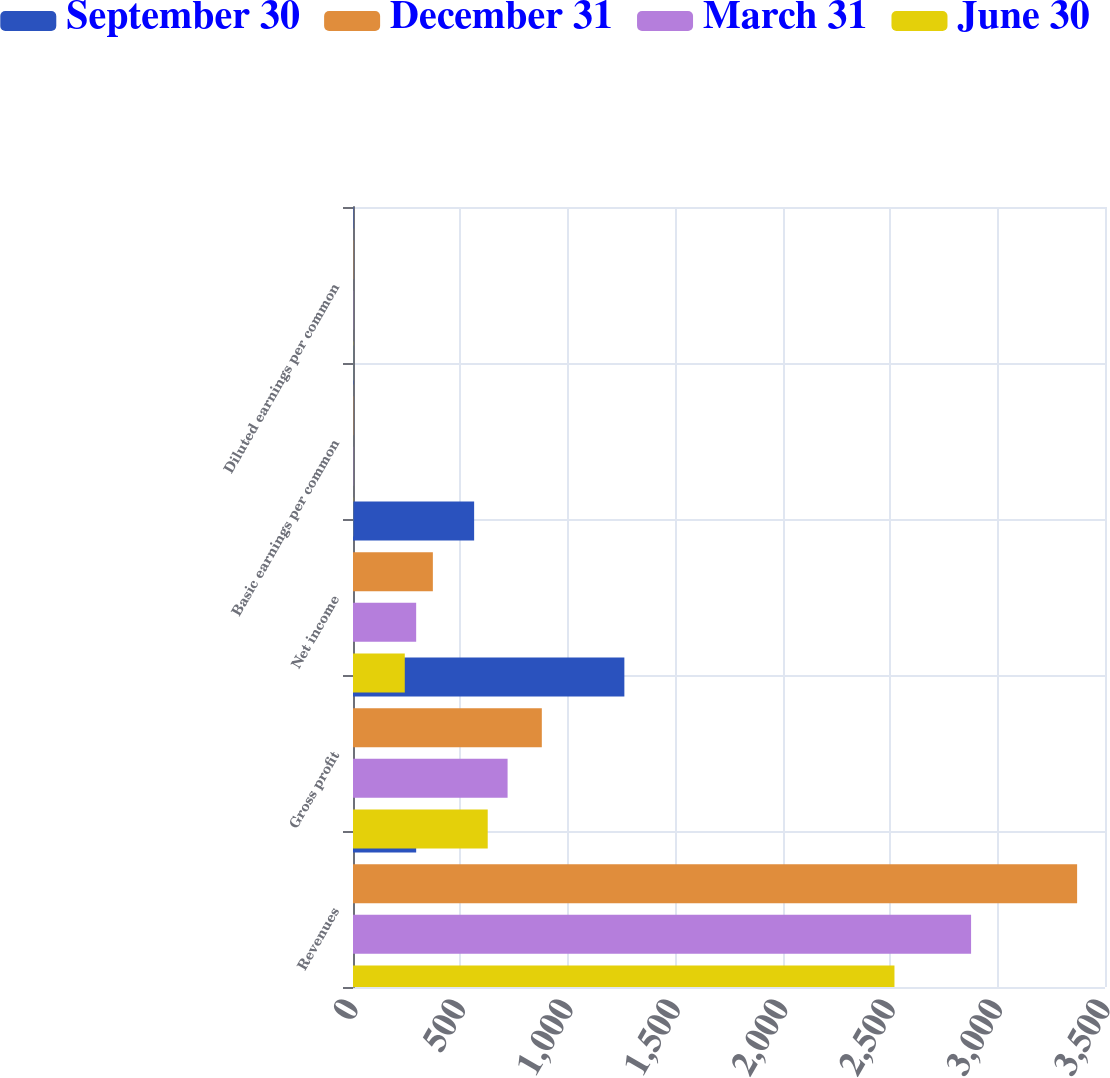<chart> <loc_0><loc_0><loc_500><loc_500><stacked_bar_chart><ecel><fcel>Revenues<fcel>Gross profit<fcel>Net income<fcel>Basic earnings per common<fcel>Diluted earnings per common<nl><fcel>September 30<fcel>294<fcel>1263<fcel>563.8<fcel>1.8<fcel>1.77<nl><fcel>December 31<fcel>3370.2<fcel>878.8<fcel>371.7<fcel>1.19<fcel>1.17<nl><fcel>March 31<fcel>2876.7<fcel>719.5<fcel>294<fcel>0.94<fcel>0.92<nl><fcel>June 30<fcel>2520.1<fcel>627<fcel>241<fcel>0.77<fcel>0.76<nl></chart> 